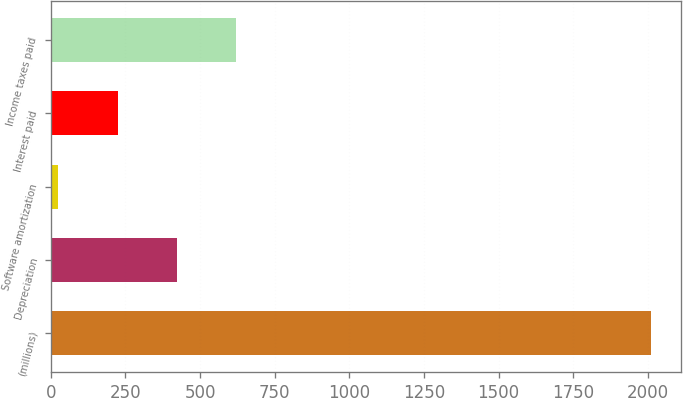Convert chart. <chart><loc_0><loc_0><loc_500><loc_500><bar_chart><fcel>(millions)<fcel>Depreciation<fcel>Software amortization<fcel>Interest paid<fcel>Income taxes paid<nl><fcel>2010<fcel>422<fcel>25<fcel>223.5<fcel>620.5<nl></chart> 